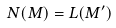Convert formula to latex. <formula><loc_0><loc_0><loc_500><loc_500>N ( M ) = L ( M ^ { \prime } )</formula> 